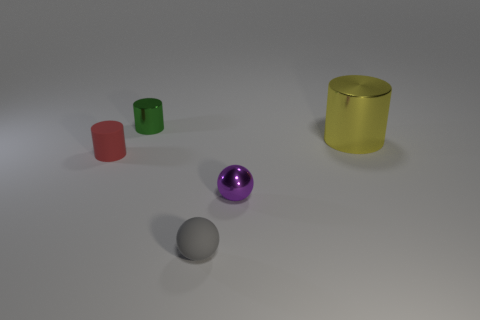Are there any big objects made of the same material as the tiny red thing?
Give a very brief answer. No. What color is the small metallic cylinder?
Your response must be concise. Green. What is the size of the cylinder that is to the right of the sphere right of the gray ball in front of the yellow metal object?
Your answer should be very brief. Large. How many other objects are there of the same shape as the yellow object?
Your answer should be very brief. 2. What color is the metallic object that is behind the purple shiny ball and right of the gray ball?
Offer a terse response. Yellow. Are there any other things that have the same size as the red cylinder?
Your answer should be very brief. Yes. There is a rubber object that is on the right side of the small red cylinder; is its color the same as the rubber cylinder?
Your answer should be very brief. No. What number of balls are either small red rubber things or large metallic things?
Your answer should be compact. 0. The object to the right of the purple shiny thing has what shape?
Keep it short and to the point. Cylinder. What is the color of the metal object that is in front of the metallic cylinder that is in front of the cylinder that is behind the yellow cylinder?
Make the answer very short. Purple. 